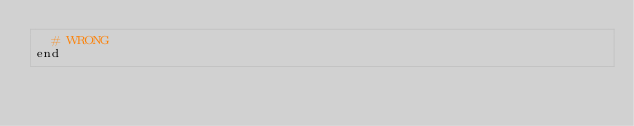<code> <loc_0><loc_0><loc_500><loc_500><_Ruby_>  # WRONG
end
</code> 